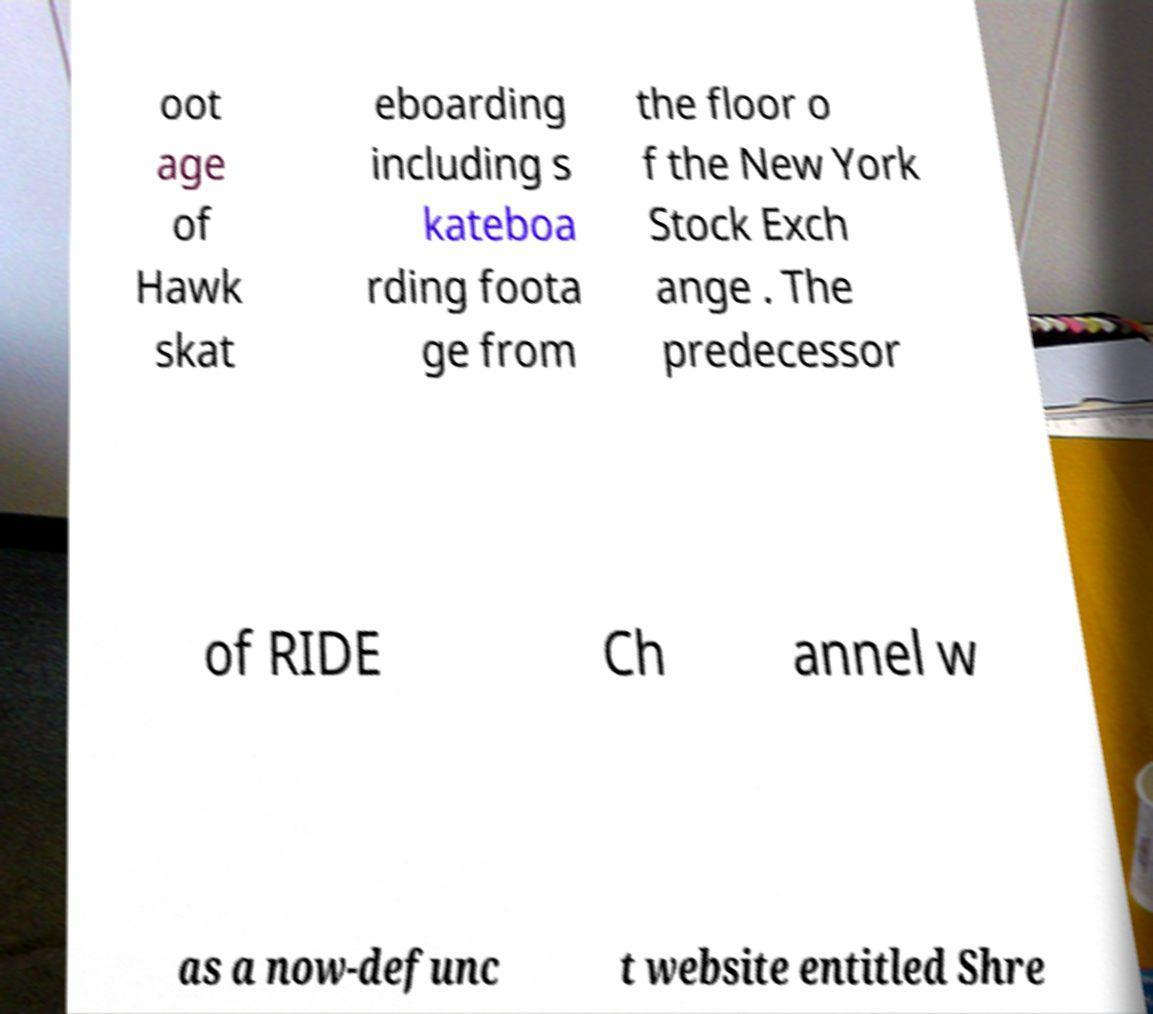Please read and relay the text visible in this image. What does it say? oot age of Hawk skat eboarding including s kateboa rding foota ge from the floor o f the New York Stock Exch ange . The predecessor of RIDE Ch annel w as a now-defunc t website entitled Shre 